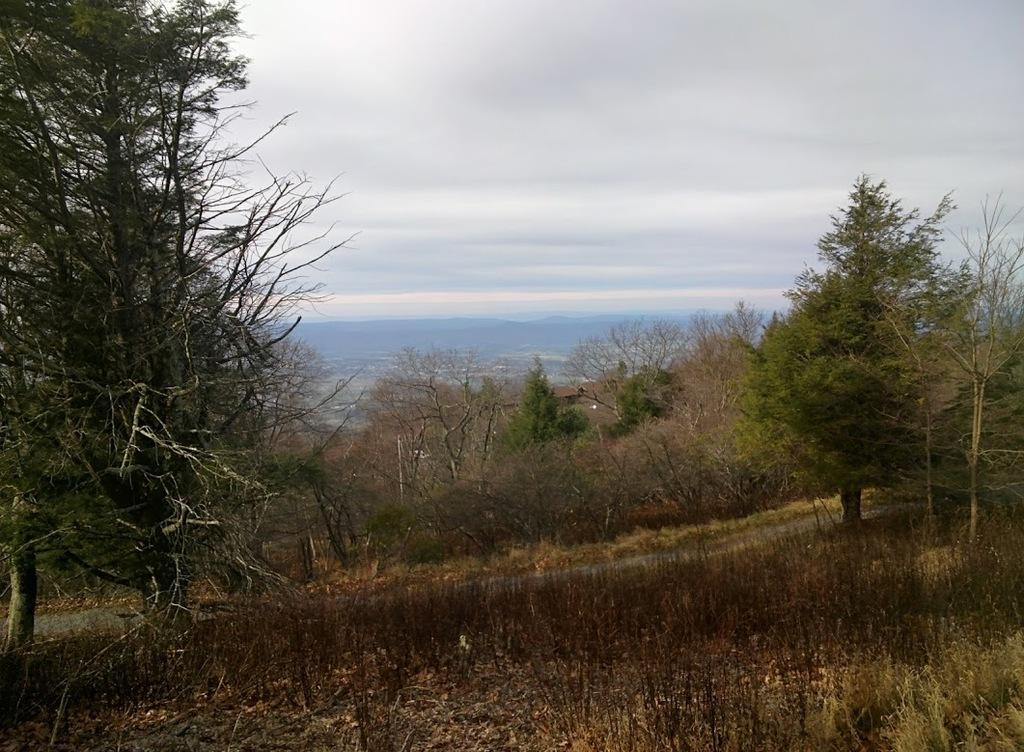What type of surface can be seen in the image? There is a road in the image. What type of vegetation is present in the image? There is grass and trees in the image. What is visible in the background of the image? The sky is visible in the image. What can be seen in the sky? Clouds are present in the sky. What is the price of the loaf of bread in the image? There is no loaf of bread present in the image, so it is not possible to determine its price. 